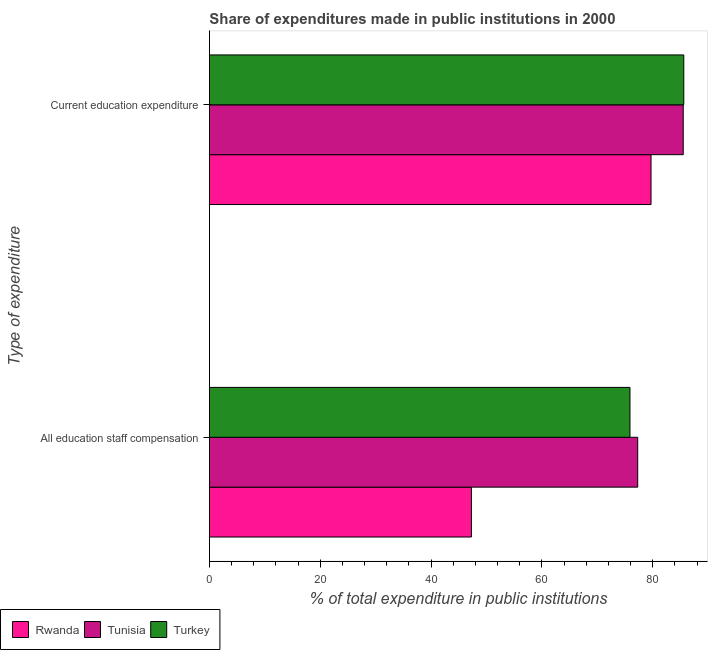How many groups of bars are there?
Offer a terse response. 2. Are the number of bars on each tick of the Y-axis equal?
Your answer should be very brief. Yes. What is the label of the 2nd group of bars from the top?
Provide a short and direct response. All education staff compensation. What is the expenditure in staff compensation in Turkey?
Your response must be concise. 75.9. Across all countries, what is the maximum expenditure in staff compensation?
Provide a short and direct response. 77.3. Across all countries, what is the minimum expenditure in staff compensation?
Provide a short and direct response. 47.29. In which country was the expenditure in staff compensation maximum?
Your answer should be compact. Tunisia. In which country was the expenditure in education minimum?
Offer a terse response. Rwanda. What is the total expenditure in staff compensation in the graph?
Give a very brief answer. 200.48. What is the difference between the expenditure in staff compensation in Tunisia and that in Rwanda?
Your answer should be compact. 30.01. What is the difference between the expenditure in staff compensation in Turkey and the expenditure in education in Rwanda?
Your answer should be compact. -3.8. What is the average expenditure in education per country?
Ensure brevity in your answer.  83.61. What is the difference between the expenditure in staff compensation and expenditure in education in Turkey?
Your answer should be compact. -9.71. In how many countries, is the expenditure in education greater than 84 %?
Offer a terse response. 2. What is the ratio of the expenditure in staff compensation in Turkey to that in Tunisia?
Keep it short and to the point. 0.98. In how many countries, is the expenditure in education greater than the average expenditure in education taken over all countries?
Provide a succinct answer. 2. What does the 1st bar from the top in Current education expenditure represents?
Provide a short and direct response. Turkey. What does the 1st bar from the bottom in All education staff compensation represents?
Provide a short and direct response. Rwanda. How many countries are there in the graph?
Offer a very short reply. 3. What is the difference between two consecutive major ticks on the X-axis?
Make the answer very short. 20. Does the graph contain any zero values?
Offer a very short reply. No. Does the graph contain grids?
Provide a succinct answer. No. How many legend labels are there?
Your answer should be compact. 3. How are the legend labels stacked?
Your answer should be compact. Horizontal. What is the title of the graph?
Provide a short and direct response. Share of expenditures made in public institutions in 2000. Does "Marshall Islands" appear as one of the legend labels in the graph?
Your answer should be compact. No. What is the label or title of the X-axis?
Ensure brevity in your answer.  % of total expenditure in public institutions. What is the label or title of the Y-axis?
Provide a short and direct response. Type of expenditure. What is the % of total expenditure in public institutions in Rwanda in All education staff compensation?
Give a very brief answer. 47.29. What is the % of total expenditure in public institutions in Tunisia in All education staff compensation?
Make the answer very short. 77.3. What is the % of total expenditure in public institutions of Turkey in All education staff compensation?
Give a very brief answer. 75.9. What is the % of total expenditure in public institutions of Rwanda in Current education expenditure?
Your answer should be very brief. 79.7. What is the % of total expenditure in public institutions in Tunisia in Current education expenditure?
Your answer should be compact. 85.51. What is the % of total expenditure in public institutions of Turkey in Current education expenditure?
Offer a terse response. 85.61. Across all Type of expenditure, what is the maximum % of total expenditure in public institutions of Rwanda?
Your response must be concise. 79.7. Across all Type of expenditure, what is the maximum % of total expenditure in public institutions in Tunisia?
Offer a very short reply. 85.51. Across all Type of expenditure, what is the maximum % of total expenditure in public institutions of Turkey?
Make the answer very short. 85.61. Across all Type of expenditure, what is the minimum % of total expenditure in public institutions in Rwanda?
Your answer should be compact. 47.29. Across all Type of expenditure, what is the minimum % of total expenditure in public institutions of Tunisia?
Your answer should be very brief. 77.3. Across all Type of expenditure, what is the minimum % of total expenditure in public institutions in Turkey?
Your answer should be very brief. 75.9. What is the total % of total expenditure in public institutions of Rwanda in the graph?
Provide a succinct answer. 126.99. What is the total % of total expenditure in public institutions of Tunisia in the graph?
Provide a succinct answer. 162.81. What is the total % of total expenditure in public institutions in Turkey in the graph?
Your response must be concise. 161.51. What is the difference between the % of total expenditure in public institutions in Rwanda in All education staff compensation and that in Current education expenditure?
Provide a succinct answer. -32.42. What is the difference between the % of total expenditure in public institutions in Tunisia in All education staff compensation and that in Current education expenditure?
Provide a short and direct response. -8.22. What is the difference between the % of total expenditure in public institutions in Turkey in All education staff compensation and that in Current education expenditure?
Make the answer very short. -9.71. What is the difference between the % of total expenditure in public institutions of Rwanda in All education staff compensation and the % of total expenditure in public institutions of Tunisia in Current education expenditure?
Give a very brief answer. -38.23. What is the difference between the % of total expenditure in public institutions in Rwanda in All education staff compensation and the % of total expenditure in public institutions in Turkey in Current education expenditure?
Make the answer very short. -38.32. What is the difference between the % of total expenditure in public institutions of Tunisia in All education staff compensation and the % of total expenditure in public institutions of Turkey in Current education expenditure?
Provide a short and direct response. -8.32. What is the average % of total expenditure in public institutions in Rwanda per Type of expenditure?
Ensure brevity in your answer.  63.49. What is the average % of total expenditure in public institutions of Tunisia per Type of expenditure?
Your response must be concise. 81.41. What is the average % of total expenditure in public institutions in Turkey per Type of expenditure?
Your response must be concise. 80.76. What is the difference between the % of total expenditure in public institutions in Rwanda and % of total expenditure in public institutions in Tunisia in All education staff compensation?
Ensure brevity in your answer.  -30.01. What is the difference between the % of total expenditure in public institutions of Rwanda and % of total expenditure in public institutions of Turkey in All education staff compensation?
Your response must be concise. -28.61. What is the difference between the % of total expenditure in public institutions in Tunisia and % of total expenditure in public institutions in Turkey in All education staff compensation?
Keep it short and to the point. 1.39. What is the difference between the % of total expenditure in public institutions in Rwanda and % of total expenditure in public institutions in Tunisia in Current education expenditure?
Your answer should be compact. -5.81. What is the difference between the % of total expenditure in public institutions of Rwanda and % of total expenditure in public institutions of Turkey in Current education expenditure?
Offer a terse response. -5.91. What is the difference between the % of total expenditure in public institutions in Tunisia and % of total expenditure in public institutions in Turkey in Current education expenditure?
Your answer should be very brief. -0.1. What is the ratio of the % of total expenditure in public institutions of Rwanda in All education staff compensation to that in Current education expenditure?
Offer a very short reply. 0.59. What is the ratio of the % of total expenditure in public institutions in Tunisia in All education staff compensation to that in Current education expenditure?
Give a very brief answer. 0.9. What is the ratio of the % of total expenditure in public institutions in Turkey in All education staff compensation to that in Current education expenditure?
Offer a very short reply. 0.89. What is the difference between the highest and the second highest % of total expenditure in public institutions in Rwanda?
Offer a terse response. 32.42. What is the difference between the highest and the second highest % of total expenditure in public institutions of Tunisia?
Your answer should be very brief. 8.22. What is the difference between the highest and the second highest % of total expenditure in public institutions of Turkey?
Your response must be concise. 9.71. What is the difference between the highest and the lowest % of total expenditure in public institutions in Rwanda?
Your answer should be very brief. 32.42. What is the difference between the highest and the lowest % of total expenditure in public institutions of Tunisia?
Keep it short and to the point. 8.22. What is the difference between the highest and the lowest % of total expenditure in public institutions in Turkey?
Make the answer very short. 9.71. 